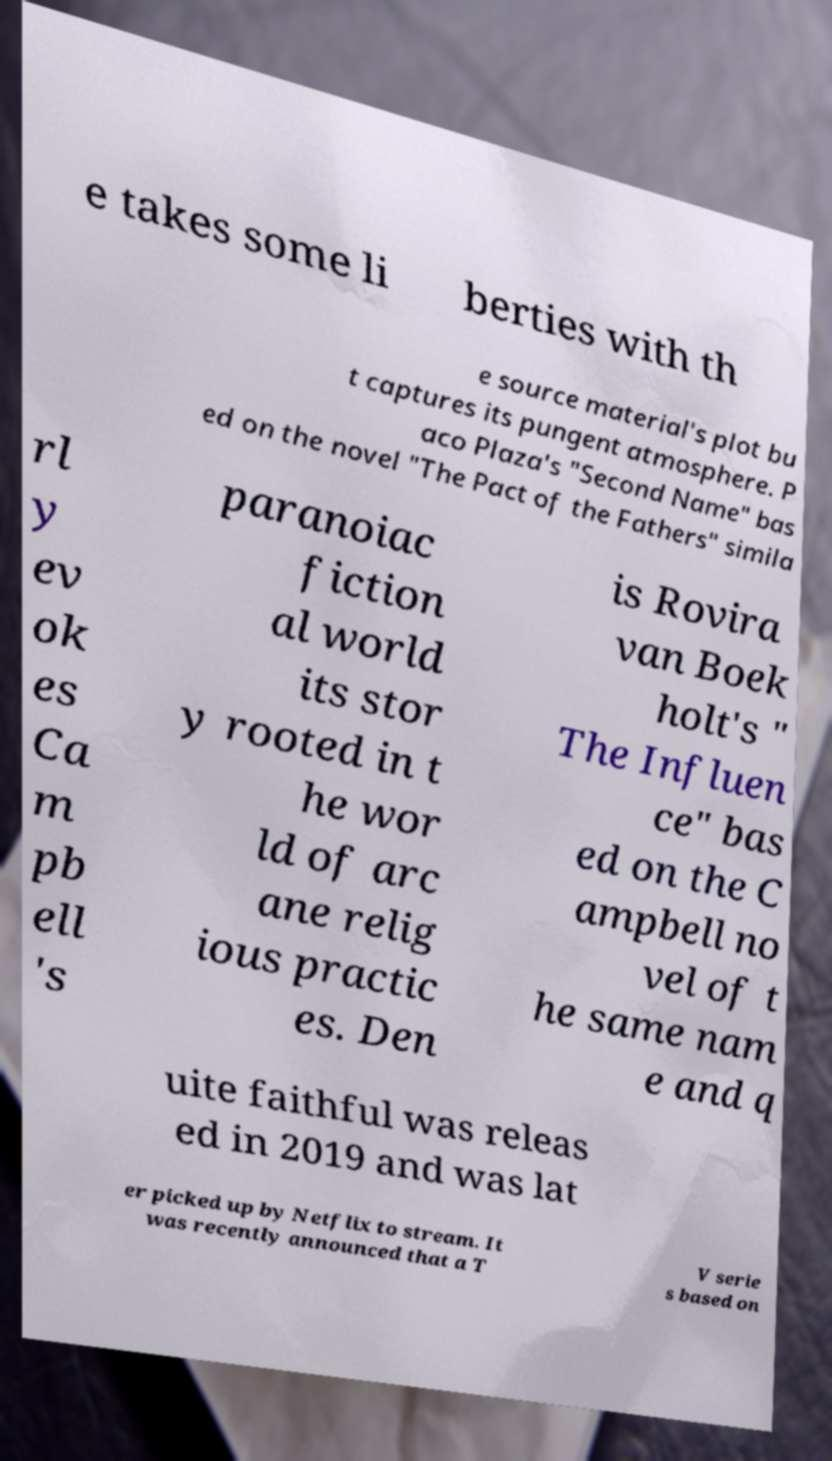For documentation purposes, I need the text within this image transcribed. Could you provide that? e takes some li berties with th e source material's plot bu t captures its pungent atmosphere. P aco Plaza's "Second Name" bas ed on the novel "The Pact of the Fathers" simila rl y ev ok es Ca m pb ell 's paranoiac fiction al world its stor y rooted in t he wor ld of arc ane relig ious practic es. Den is Rovira van Boek holt's " The Influen ce" bas ed on the C ampbell no vel of t he same nam e and q uite faithful was releas ed in 2019 and was lat er picked up by Netflix to stream. It was recently announced that a T V serie s based on 